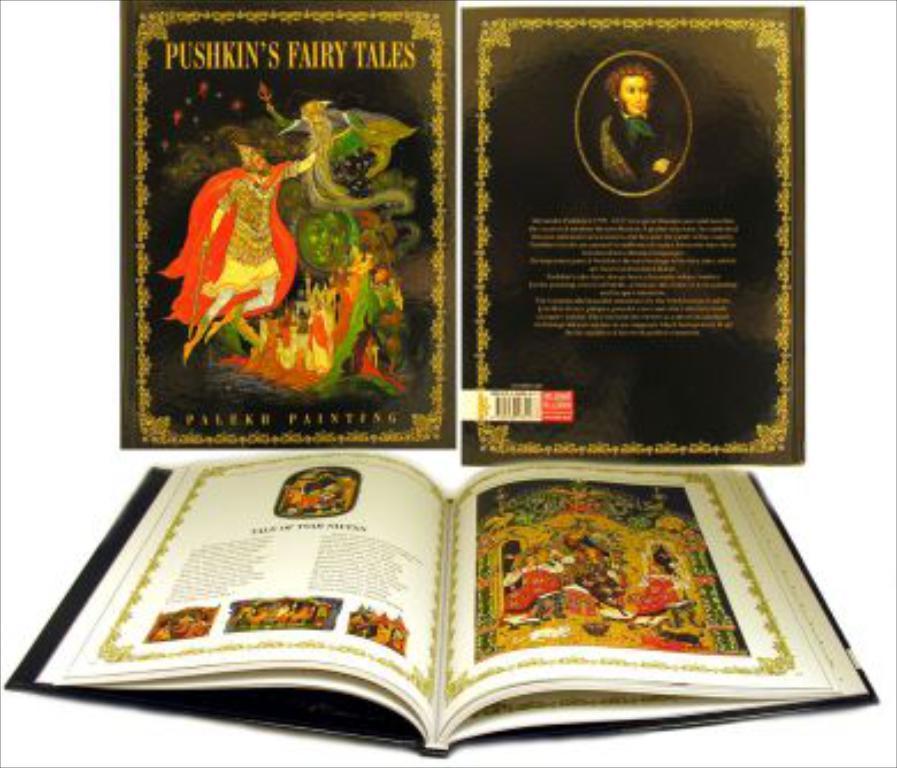Please provide a concise description of this image. In this image, I can see a book and book covers with words and pictures of people. There is a white background. 